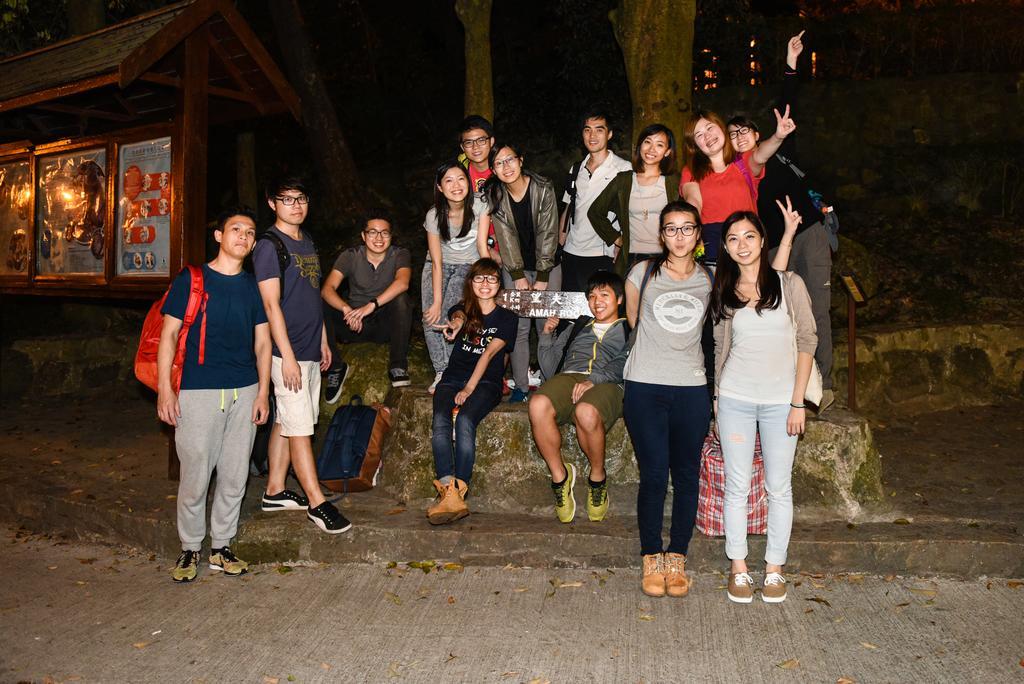Describe this image in one or two sentences. In this picture we can see some people are standing, these three persons are sitting, a person on the left side is carrying a backpack, on the left side there is a shed, we can see a tree here. 